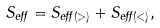Convert formula to latex. <formula><loc_0><loc_0><loc_500><loc_500>S _ { e f f } = S _ { e f f ( > ) } + S _ { e f f ( < ) } ,</formula> 